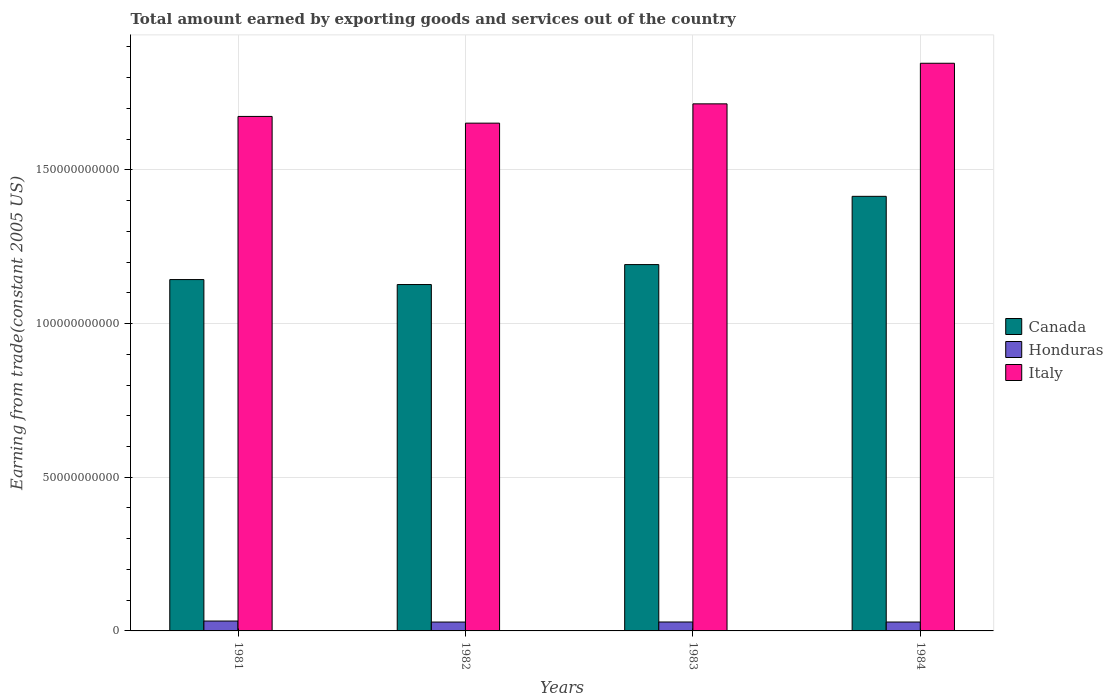How many different coloured bars are there?
Provide a short and direct response. 3. Are the number of bars on each tick of the X-axis equal?
Offer a terse response. Yes. How many bars are there on the 2nd tick from the left?
Your answer should be compact. 3. What is the label of the 4th group of bars from the left?
Keep it short and to the point. 1984. What is the total amount earned by exporting goods and services in Italy in 1982?
Offer a very short reply. 1.65e+11. Across all years, what is the maximum total amount earned by exporting goods and services in Canada?
Your answer should be very brief. 1.41e+11. Across all years, what is the minimum total amount earned by exporting goods and services in Italy?
Your answer should be compact. 1.65e+11. In which year was the total amount earned by exporting goods and services in Canada maximum?
Offer a very short reply. 1984. What is the total total amount earned by exporting goods and services in Honduras in the graph?
Your answer should be very brief. 1.19e+1. What is the difference between the total amount earned by exporting goods and services in Italy in 1982 and that in 1984?
Keep it short and to the point. -1.95e+1. What is the difference between the total amount earned by exporting goods and services in Italy in 1981 and the total amount earned by exporting goods and services in Honduras in 1982?
Offer a very short reply. 1.65e+11. What is the average total amount earned by exporting goods and services in Honduras per year?
Your answer should be compact. 2.98e+09. In the year 1984, what is the difference between the total amount earned by exporting goods and services in Honduras and total amount earned by exporting goods and services in Italy?
Make the answer very short. -1.82e+11. What is the ratio of the total amount earned by exporting goods and services in Italy in 1981 to that in 1984?
Your response must be concise. 0.91. Is the total amount earned by exporting goods and services in Honduras in 1981 less than that in 1984?
Ensure brevity in your answer.  No. What is the difference between the highest and the second highest total amount earned by exporting goods and services in Honduras?
Keep it short and to the point. 3.07e+08. What is the difference between the highest and the lowest total amount earned by exporting goods and services in Italy?
Provide a succinct answer. 1.95e+1. In how many years, is the total amount earned by exporting goods and services in Canada greater than the average total amount earned by exporting goods and services in Canada taken over all years?
Give a very brief answer. 1. What does the 2nd bar from the left in 1982 represents?
Your response must be concise. Honduras. Is it the case that in every year, the sum of the total amount earned by exporting goods and services in Italy and total amount earned by exporting goods and services in Honduras is greater than the total amount earned by exporting goods and services in Canada?
Offer a very short reply. Yes. Does the graph contain grids?
Your answer should be compact. Yes. Where does the legend appear in the graph?
Provide a short and direct response. Center right. What is the title of the graph?
Make the answer very short. Total amount earned by exporting goods and services out of the country. Does "St. Lucia" appear as one of the legend labels in the graph?
Keep it short and to the point. No. What is the label or title of the X-axis?
Provide a succinct answer. Years. What is the label or title of the Y-axis?
Give a very brief answer. Earning from trade(constant 2005 US). What is the Earning from trade(constant 2005 US) of Canada in 1981?
Offer a terse response. 1.14e+11. What is the Earning from trade(constant 2005 US) of Honduras in 1981?
Offer a terse response. 3.21e+09. What is the Earning from trade(constant 2005 US) in Italy in 1981?
Your answer should be very brief. 1.67e+11. What is the Earning from trade(constant 2005 US) of Canada in 1982?
Provide a succinct answer. 1.13e+11. What is the Earning from trade(constant 2005 US) of Honduras in 1982?
Make the answer very short. 2.89e+09. What is the Earning from trade(constant 2005 US) of Italy in 1982?
Keep it short and to the point. 1.65e+11. What is the Earning from trade(constant 2005 US) in Canada in 1983?
Your answer should be compact. 1.19e+11. What is the Earning from trade(constant 2005 US) of Honduras in 1983?
Your response must be concise. 2.91e+09. What is the Earning from trade(constant 2005 US) of Italy in 1983?
Your answer should be compact. 1.71e+11. What is the Earning from trade(constant 2005 US) of Canada in 1984?
Your answer should be very brief. 1.41e+11. What is the Earning from trade(constant 2005 US) of Honduras in 1984?
Ensure brevity in your answer.  2.90e+09. What is the Earning from trade(constant 2005 US) of Italy in 1984?
Your answer should be very brief. 1.85e+11. Across all years, what is the maximum Earning from trade(constant 2005 US) in Canada?
Give a very brief answer. 1.41e+11. Across all years, what is the maximum Earning from trade(constant 2005 US) in Honduras?
Offer a terse response. 3.21e+09. Across all years, what is the maximum Earning from trade(constant 2005 US) of Italy?
Ensure brevity in your answer.  1.85e+11. Across all years, what is the minimum Earning from trade(constant 2005 US) in Canada?
Your response must be concise. 1.13e+11. Across all years, what is the minimum Earning from trade(constant 2005 US) in Honduras?
Your answer should be compact. 2.89e+09. Across all years, what is the minimum Earning from trade(constant 2005 US) of Italy?
Keep it short and to the point. 1.65e+11. What is the total Earning from trade(constant 2005 US) of Canada in the graph?
Make the answer very short. 4.88e+11. What is the total Earning from trade(constant 2005 US) in Honduras in the graph?
Give a very brief answer. 1.19e+1. What is the total Earning from trade(constant 2005 US) of Italy in the graph?
Your answer should be very brief. 6.89e+11. What is the difference between the Earning from trade(constant 2005 US) in Canada in 1981 and that in 1982?
Provide a short and direct response. 1.61e+09. What is the difference between the Earning from trade(constant 2005 US) in Honduras in 1981 and that in 1982?
Your answer should be compact. 3.28e+08. What is the difference between the Earning from trade(constant 2005 US) of Italy in 1981 and that in 1982?
Offer a very short reply. 2.19e+09. What is the difference between the Earning from trade(constant 2005 US) in Canada in 1981 and that in 1983?
Offer a very short reply. -4.88e+09. What is the difference between the Earning from trade(constant 2005 US) of Honduras in 1981 and that in 1983?
Provide a succinct answer. 3.07e+08. What is the difference between the Earning from trade(constant 2005 US) of Italy in 1981 and that in 1983?
Ensure brevity in your answer.  -4.09e+09. What is the difference between the Earning from trade(constant 2005 US) in Canada in 1981 and that in 1984?
Ensure brevity in your answer.  -2.71e+1. What is the difference between the Earning from trade(constant 2005 US) in Honduras in 1981 and that in 1984?
Your answer should be compact. 3.20e+08. What is the difference between the Earning from trade(constant 2005 US) in Italy in 1981 and that in 1984?
Make the answer very short. -1.73e+1. What is the difference between the Earning from trade(constant 2005 US) of Canada in 1982 and that in 1983?
Provide a short and direct response. -6.49e+09. What is the difference between the Earning from trade(constant 2005 US) in Honduras in 1982 and that in 1983?
Ensure brevity in your answer.  -2.08e+07. What is the difference between the Earning from trade(constant 2005 US) in Italy in 1982 and that in 1983?
Provide a succinct answer. -6.28e+09. What is the difference between the Earning from trade(constant 2005 US) of Canada in 1982 and that in 1984?
Provide a succinct answer. -2.87e+1. What is the difference between the Earning from trade(constant 2005 US) in Honduras in 1982 and that in 1984?
Your answer should be very brief. -8.30e+06. What is the difference between the Earning from trade(constant 2005 US) in Italy in 1982 and that in 1984?
Ensure brevity in your answer.  -1.95e+1. What is the difference between the Earning from trade(constant 2005 US) in Canada in 1983 and that in 1984?
Your response must be concise. -2.22e+1. What is the difference between the Earning from trade(constant 2005 US) in Honduras in 1983 and that in 1984?
Ensure brevity in your answer.  1.25e+07. What is the difference between the Earning from trade(constant 2005 US) of Italy in 1983 and that in 1984?
Provide a short and direct response. -1.32e+1. What is the difference between the Earning from trade(constant 2005 US) in Canada in 1981 and the Earning from trade(constant 2005 US) in Honduras in 1982?
Provide a succinct answer. 1.11e+11. What is the difference between the Earning from trade(constant 2005 US) in Canada in 1981 and the Earning from trade(constant 2005 US) in Italy in 1982?
Provide a short and direct response. -5.09e+1. What is the difference between the Earning from trade(constant 2005 US) in Honduras in 1981 and the Earning from trade(constant 2005 US) in Italy in 1982?
Make the answer very short. -1.62e+11. What is the difference between the Earning from trade(constant 2005 US) in Canada in 1981 and the Earning from trade(constant 2005 US) in Honduras in 1983?
Your answer should be very brief. 1.11e+11. What is the difference between the Earning from trade(constant 2005 US) in Canada in 1981 and the Earning from trade(constant 2005 US) in Italy in 1983?
Ensure brevity in your answer.  -5.72e+1. What is the difference between the Earning from trade(constant 2005 US) in Honduras in 1981 and the Earning from trade(constant 2005 US) in Italy in 1983?
Provide a short and direct response. -1.68e+11. What is the difference between the Earning from trade(constant 2005 US) of Canada in 1981 and the Earning from trade(constant 2005 US) of Honduras in 1984?
Keep it short and to the point. 1.11e+11. What is the difference between the Earning from trade(constant 2005 US) in Canada in 1981 and the Earning from trade(constant 2005 US) in Italy in 1984?
Your answer should be compact. -7.04e+1. What is the difference between the Earning from trade(constant 2005 US) in Honduras in 1981 and the Earning from trade(constant 2005 US) in Italy in 1984?
Your answer should be compact. -1.81e+11. What is the difference between the Earning from trade(constant 2005 US) in Canada in 1982 and the Earning from trade(constant 2005 US) in Honduras in 1983?
Provide a short and direct response. 1.10e+11. What is the difference between the Earning from trade(constant 2005 US) in Canada in 1982 and the Earning from trade(constant 2005 US) in Italy in 1983?
Offer a very short reply. -5.88e+1. What is the difference between the Earning from trade(constant 2005 US) of Honduras in 1982 and the Earning from trade(constant 2005 US) of Italy in 1983?
Your answer should be compact. -1.69e+11. What is the difference between the Earning from trade(constant 2005 US) of Canada in 1982 and the Earning from trade(constant 2005 US) of Honduras in 1984?
Your answer should be very brief. 1.10e+11. What is the difference between the Earning from trade(constant 2005 US) in Canada in 1982 and the Earning from trade(constant 2005 US) in Italy in 1984?
Provide a short and direct response. -7.20e+1. What is the difference between the Earning from trade(constant 2005 US) in Honduras in 1982 and the Earning from trade(constant 2005 US) in Italy in 1984?
Your answer should be compact. -1.82e+11. What is the difference between the Earning from trade(constant 2005 US) in Canada in 1983 and the Earning from trade(constant 2005 US) in Honduras in 1984?
Make the answer very short. 1.16e+11. What is the difference between the Earning from trade(constant 2005 US) in Canada in 1983 and the Earning from trade(constant 2005 US) in Italy in 1984?
Provide a succinct answer. -6.55e+1. What is the difference between the Earning from trade(constant 2005 US) in Honduras in 1983 and the Earning from trade(constant 2005 US) in Italy in 1984?
Your response must be concise. -1.82e+11. What is the average Earning from trade(constant 2005 US) in Canada per year?
Provide a short and direct response. 1.22e+11. What is the average Earning from trade(constant 2005 US) of Honduras per year?
Your answer should be very brief. 2.98e+09. What is the average Earning from trade(constant 2005 US) in Italy per year?
Provide a short and direct response. 1.72e+11. In the year 1981, what is the difference between the Earning from trade(constant 2005 US) in Canada and Earning from trade(constant 2005 US) in Honduras?
Make the answer very short. 1.11e+11. In the year 1981, what is the difference between the Earning from trade(constant 2005 US) of Canada and Earning from trade(constant 2005 US) of Italy?
Your response must be concise. -5.31e+1. In the year 1981, what is the difference between the Earning from trade(constant 2005 US) of Honduras and Earning from trade(constant 2005 US) of Italy?
Give a very brief answer. -1.64e+11. In the year 1982, what is the difference between the Earning from trade(constant 2005 US) in Canada and Earning from trade(constant 2005 US) in Honduras?
Your response must be concise. 1.10e+11. In the year 1982, what is the difference between the Earning from trade(constant 2005 US) in Canada and Earning from trade(constant 2005 US) in Italy?
Offer a terse response. -5.25e+1. In the year 1982, what is the difference between the Earning from trade(constant 2005 US) in Honduras and Earning from trade(constant 2005 US) in Italy?
Keep it short and to the point. -1.62e+11. In the year 1983, what is the difference between the Earning from trade(constant 2005 US) of Canada and Earning from trade(constant 2005 US) of Honduras?
Offer a very short reply. 1.16e+11. In the year 1983, what is the difference between the Earning from trade(constant 2005 US) of Canada and Earning from trade(constant 2005 US) of Italy?
Your response must be concise. -5.23e+1. In the year 1983, what is the difference between the Earning from trade(constant 2005 US) in Honduras and Earning from trade(constant 2005 US) in Italy?
Your response must be concise. -1.69e+11. In the year 1984, what is the difference between the Earning from trade(constant 2005 US) in Canada and Earning from trade(constant 2005 US) in Honduras?
Offer a terse response. 1.39e+11. In the year 1984, what is the difference between the Earning from trade(constant 2005 US) of Canada and Earning from trade(constant 2005 US) of Italy?
Your response must be concise. -4.33e+1. In the year 1984, what is the difference between the Earning from trade(constant 2005 US) in Honduras and Earning from trade(constant 2005 US) in Italy?
Keep it short and to the point. -1.82e+11. What is the ratio of the Earning from trade(constant 2005 US) of Canada in 1981 to that in 1982?
Offer a very short reply. 1.01. What is the ratio of the Earning from trade(constant 2005 US) of Honduras in 1981 to that in 1982?
Your answer should be very brief. 1.11. What is the ratio of the Earning from trade(constant 2005 US) of Italy in 1981 to that in 1982?
Ensure brevity in your answer.  1.01. What is the ratio of the Earning from trade(constant 2005 US) of Canada in 1981 to that in 1983?
Offer a terse response. 0.96. What is the ratio of the Earning from trade(constant 2005 US) of Honduras in 1981 to that in 1983?
Your answer should be compact. 1.11. What is the ratio of the Earning from trade(constant 2005 US) of Italy in 1981 to that in 1983?
Your response must be concise. 0.98. What is the ratio of the Earning from trade(constant 2005 US) in Canada in 1981 to that in 1984?
Your answer should be compact. 0.81. What is the ratio of the Earning from trade(constant 2005 US) of Honduras in 1981 to that in 1984?
Your answer should be compact. 1.11. What is the ratio of the Earning from trade(constant 2005 US) in Italy in 1981 to that in 1984?
Ensure brevity in your answer.  0.91. What is the ratio of the Earning from trade(constant 2005 US) of Canada in 1982 to that in 1983?
Provide a short and direct response. 0.95. What is the ratio of the Earning from trade(constant 2005 US) in Honduras in 1982 to that in 1983?
Your answer should be very brief. 0.99. What is the ratio of the Earning from trade(constant 2005 US) of Italy in 1982 to that in 1983?
Offer a terse response. 0.96. What is the ratio of the Earning from trade(constant 2005 US) in Canada in 1982 to that in 1984?
Your answer should be very brief. 0.8. What is the ratio of the Earning from trade(constant 2005 US) of Italy in 1982 to that in 1984?
Keep it short and to the point. 0.89. What is the ratio of the Earning from trade(constant 2005 US) of Canada in 1983 to that in 1984?
Keep it short and to the point. 0.84. What is the ratio of the Earning from trade(constant 2005 US) in Honduras in 1983 to that in 1984?
Provide a short and direct response. 1. What is the ratio of the Earning from trade(constant 2005 US) of Italy in 1983 to that in 1984?
Your answer should be compact. 0.93. What is the difference between the highest and the second highest Earning from trade(constant 2005 US) in Canada?
Offer a terse response. 2.22e+1. What is the difference between the highest and the second highest Earning from trade(constant 2005 US) in Honduras?
Give a very brief answer. 3.07e+08. What is the difference between the highest and the second highest Earning from trade(constant 2005 US) of Italy?
Your answer should be very brief. 1.32e+1. What is the difference between the highest and the lowest Earning from trade(constant 2005 US) of Canada?
Your answer should be very brief. 2.87e+1. What is the difference between the highest and the lowest Earning from trade(constant 2005 US) in Honduras?
Offer a very short reply. 3.28e+08. What is the difference between the highest and the lowest Earning from trade(constant 2005 US) in Italy?
Offer a terse response. 1.95e+1. 